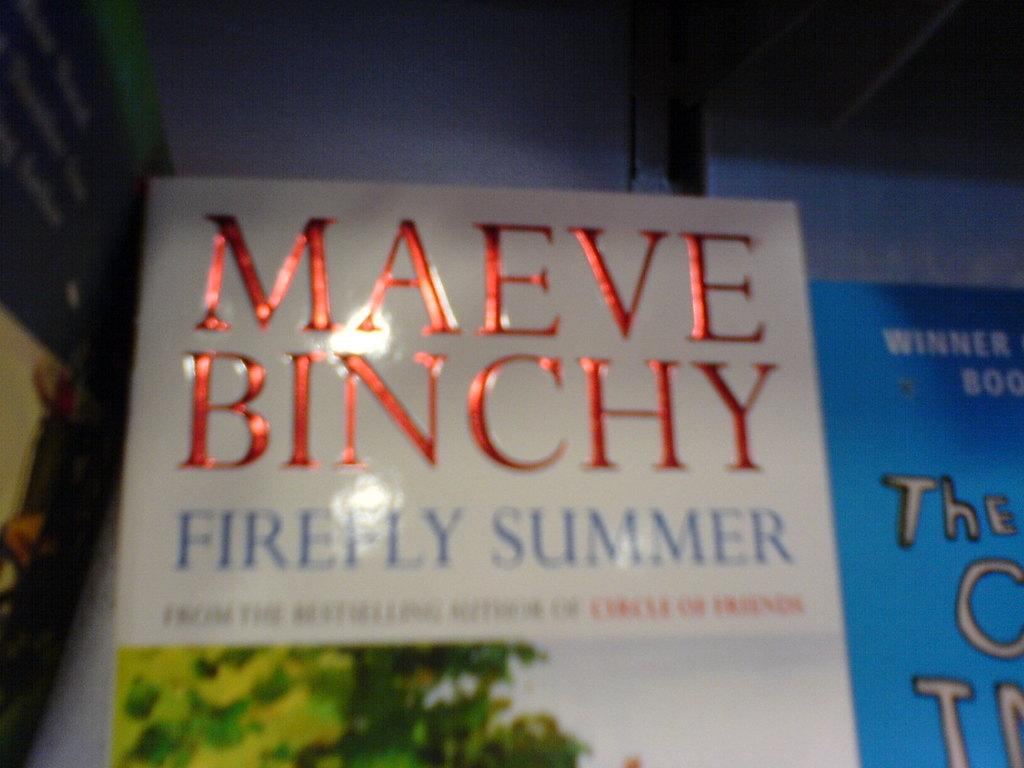<image>
Render a clear and concise summary of the photo. The book Firefly Summer written by Maeve Binchy 